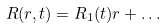Convert formula to latex. <formula><loc_0><loc_0><loc_500><loc_500>R ( r , t ) = R _ { 1 } ( t ) r + \dots</formula> 